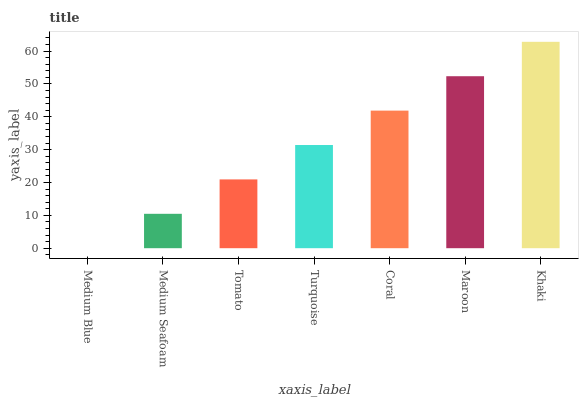Is Medium Blue the minimum?
Answer yes or no. Yes. Is Khaki the maximum?
Answer yes or no. Yes. Is Medium Seafoam the minimum?
Answer yes or no. No. Is Medium Seafoam the maximum?
Answer yes or no. No. Is Medium Seafoam greater than Medium Blue?
Answer yes or no. Yes. Is Medium Blue less than Medium Seafoam?
Answer yes or no. Yes. Is Medium Blue greater than Medium Seafoam?
Answer yes or no. No. Is Medium Seafoam less than Medium Blue?
Answer yes or no. No. Is Turquoise the high median?
Answer yes or no. Yes. Is Turquoise the low median?
Answer yes or no. Yes. Is Medium Seafoam the high median?
Answer yes or no. No. Is Tomato the low median?
Answer yes or no. No. 